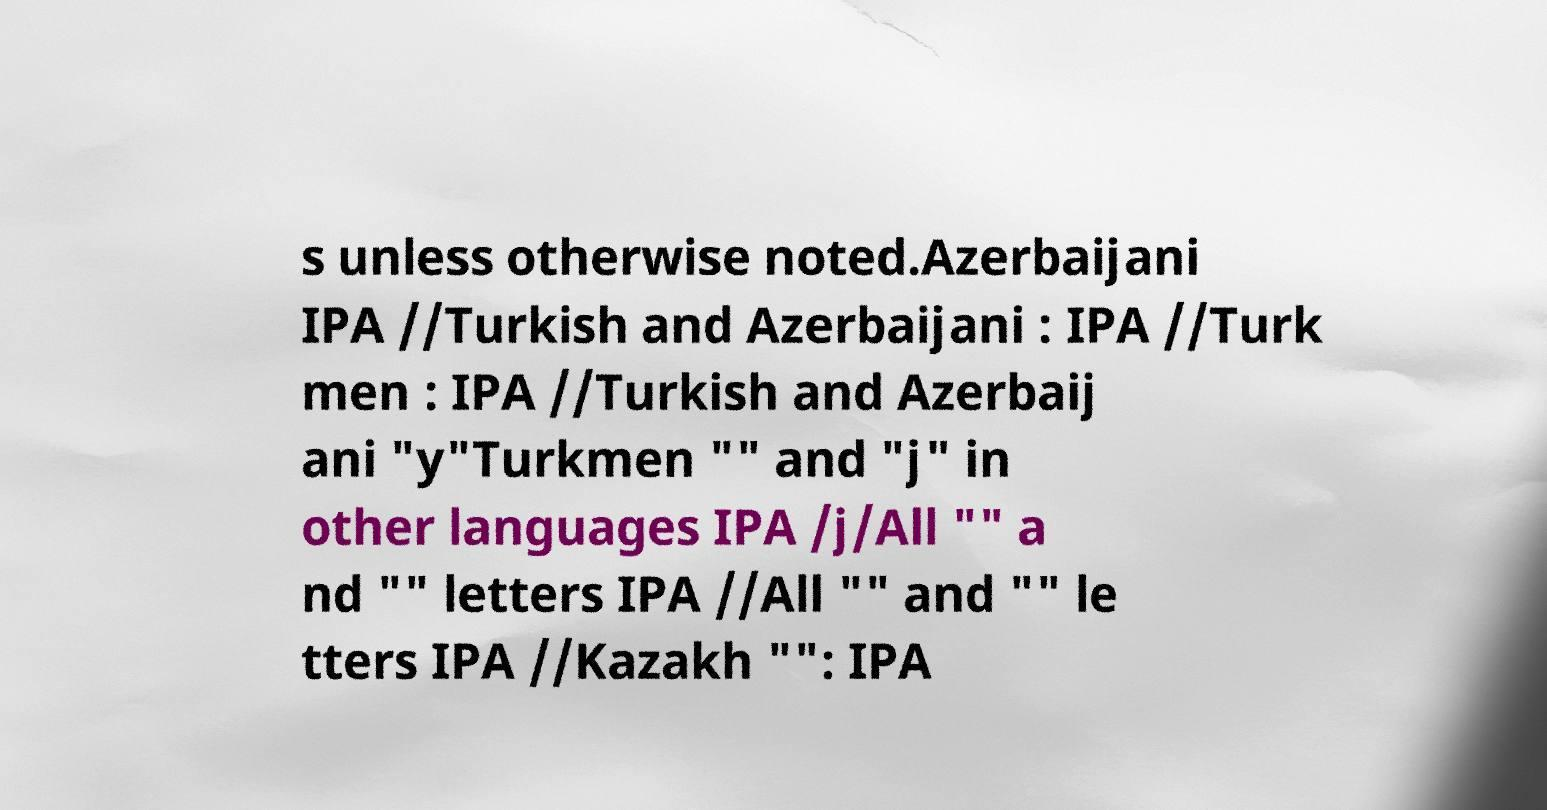Could you extract and type out the text from this image? s unless otherwise noted.Azerbaijani IPA //Turkish and Azerbaijani : IPA //Turk men : IPA //Turkish and Azerbaij ani "y"Turkmen "" and "j" in other languages IPA /j/All "" a nd "" letters IPA //All "" and "" le tters IPA //Kazakh "": IPA 